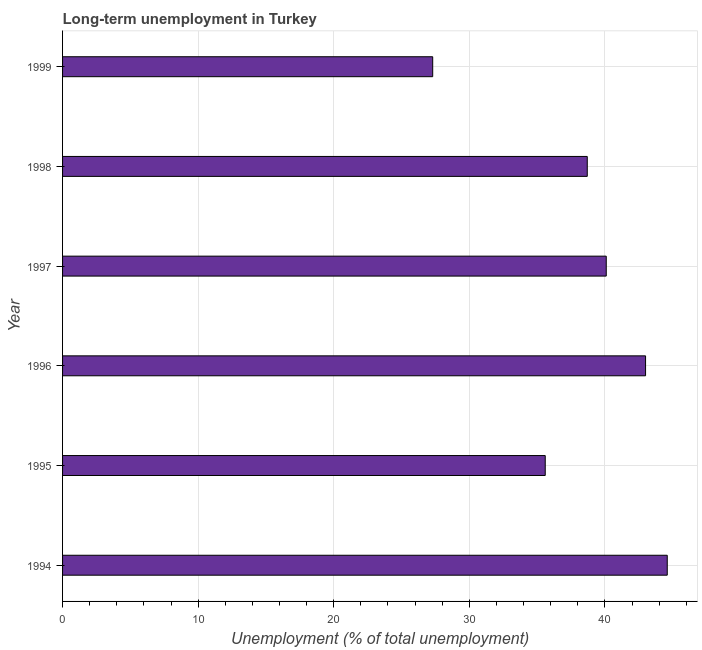What is the title of the graph?
Offer a terse response. Long-term unemployment in Turkey. What is the label or title of the X-axis?
Make the answer very short. Unemployment (% of total unemployment). What is the label or title of the Y-axis?
Offer a terse response. Year. What is the long-term unemployment in 1997?
Your response must be concise. 40.1. Across all years, what is the maximum long-term unemployment?
Your answer should be compact. 44.6. Across all years, what is the minimum long-term unemployment?
Ensure brevity in your answer.  27.3. What is the sum of the long-term unemployment?
Offer a very short reply. 229.3. What is the difference between the long-term unemployment in 1995 and 1998?
Your answer should be compact. -3.1. What is the average long-term unemployment per year?
Keep it short and to the point. 38.22. What is the median long-term unemployment?
Your response must be concise. 39.4. What is the ratio of the long-term unemployment in 1994 to that in 1995?
Your response must be concise. 1.25. Is the long-term unemployment in 1996 less than that in 1998?
Provide a short and direct response. No. What is the difference between the highest and the second highest long-term unemployment?
Offer a terse response. 1.6. In how many years, is the long-term unemployment greater than the average long-term unemployment taken over all years?
Your answer should be very brief. 4. What is the difference between two consecutive major ticks on the X-axis?
Give a very brief answer. 10. What is the Unemployment (% of total unemployment) in 1994?
Offer a terse response. 44.6. What is the Unemployment (% of total unemployment) of 1995?
Ensure brevity in your answer.  35.6. What is the Unemployment (% of total unemployment) in 1997?
Keep it short and to the point. 40.1. What is the Unemployment (% of total unemployment) in 1998?
Keep it short and to the point. 38.7. What is the Unemployment (% of total unemployment) of 1999?
Give a very brief answer. 27.3. What is the difference between the Unemployment (% of total unemployment) in 1994 and 1996?
Offer a terse response. 1.6. What is the difference between the Unemployment (% of total unemployment) in 1994 and 1997?
Your response must be concise. 4.5. What is the difference between the Unemployment (% of total unemployment) in 1995 and 1996?
Offer a terse response. -7.4. What is the difference between the Unemployment (% of total unemployment) in 1996 and 1999?
Offer a terse response. 15.7. What is the difference between the Unemployment (% of total unemployment) in 1998 and 1999?
Your response must be concise. 11.4. What is the ratio of the Unemployment (% of total unemployment) in 1994 to that in 1995?
Your response must be concise. 1.25. What is the ratio of the Unemployment (% of total unemployment) in 1994 to that in 1996?
Make the answer very short. 1.04. What is the ratio of the Unemployment (% of total unemployment) in 1994 to that in 1997?
Your answer should be very brief. 1.11. What is the ratio of the Unemployment (% of total unemployment) in 1994 to that in 1998?
Provide a succinct answer. 1.15. What is the ratio of the Unemployment (% of total unemployment) in 1994 to that in 1999?
Your response must be concise. 1.63. What is the ratio of the Unemployment (% of total unemployment) in 1995 to that in 1996?
Your answer should be very brief. 0.83. What is the ratio of the Unemployment (% of total unemployment) in 1995 to that in 1997?
Offer a terse response. 0.89. What is the ratio of the Unemployment (% of total unemployment) in 1995 to that in 1999?
Provide a succinct answer. 1.3. What is the ratio of the Unemployment (% of total unemployment) in 1996 to that in 1997?
Provide a succinct answer. 1.07. What is the ratio of the Unemployment (% of total unemployment) in 1996 to that in 1998?
Keep it short and to the point. 1.11. What is the ratio of the Unemployment (% of total unemployment) in 1996 to that in 1999?
Make the answer very short. 1.57. What is the ratio of the Unemployment (% of total unemployment) in 1997 to that in 1998?
Provide a short and direct response. 1.04. What is the ratio of the Unemployment (% of total unemployment) in 1997 to that in 1999?
Keep it short and to the point. 1.47. What is the ratio of the Unemployment (% of total unemployment) in 1998 to that in 1999?
Keep it short and to the point. 1.42. 